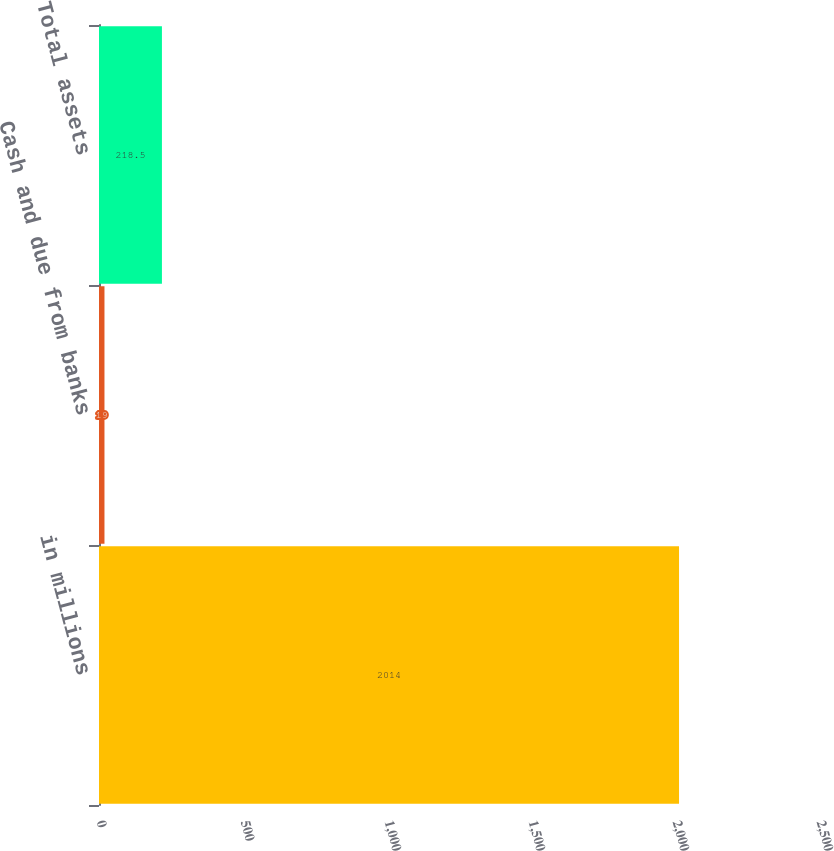Convert chart to OTSL. <chart><loc_0><loc_0><loc_500><loc_500><bar_chart><fcel>in millions<fcel>Cash and due from banks<fcel>Total assets<nl><fcel>2014<fcel>19<fcel>218.5<nl></chart> 